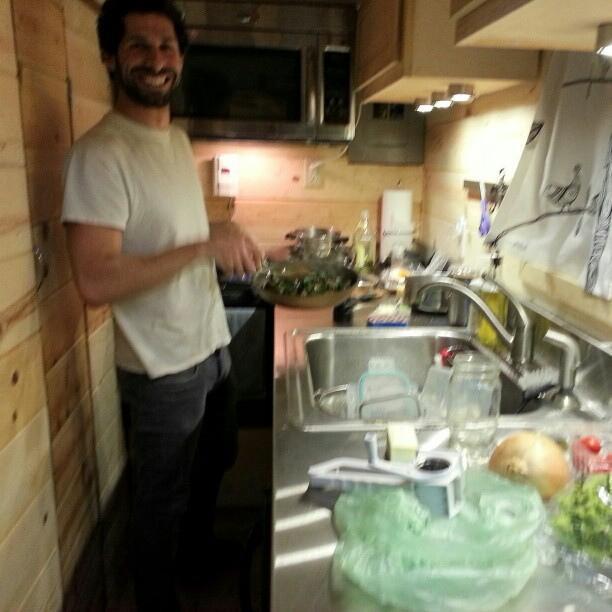How many bottles are in the photo?
Give a very brief answer. 1. How many bowls can you see?
Give a very brief answer. 1. 